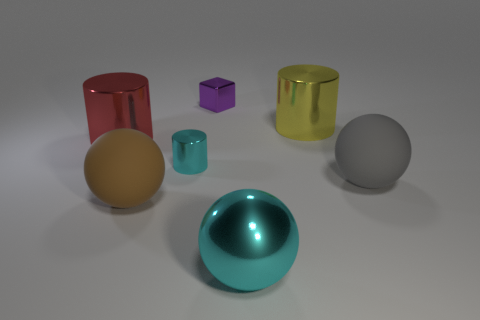Subtract all brown rubber spheres. How many spheres are left? 2 Add 1 big red metallic things. How many objects exist? 8 Subtract all cyan cylinders. How many cylinders are left? 2 Subtract all blocks. How many objects are left? 6 Subtract all red cylinders. Subtract all cyan shiny objects. How many objects are left? 4 Add 1 big cyan metallic spheres. How many big cyan metallic spheres are left? 2 Add 7 brown balls. How many brown balls exist? 8 Subtract 0 brown cylinders. How many objects are left? 7 Subtract 1 cylinders. How many cylinders are left? 2 Subtract all red cubes. Subtract all green balls. How many cubes are left? 1 